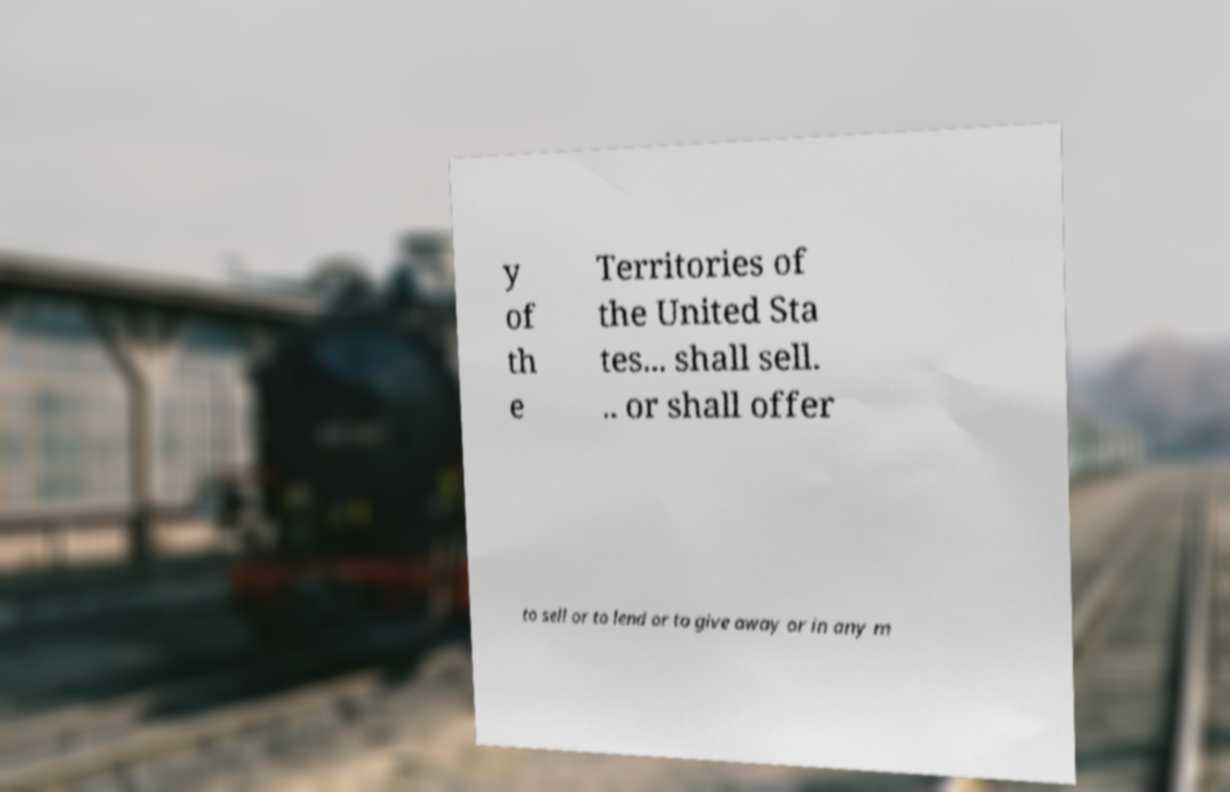Can you accurately transcribe the text from the provided image for me? y of th e Territories of the United Sta tes... shall sell. .. or shall offer to sell or to lend or to give away or in any m 